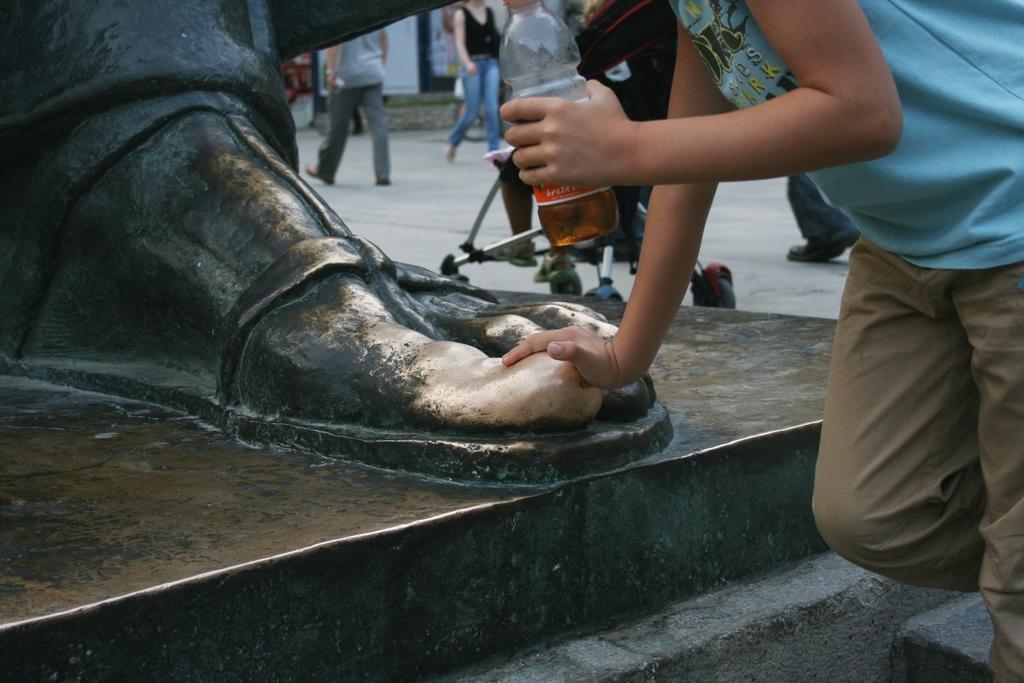Could you give a brief overview of what you see in this image? In this image I can see a sculpture and a group of people on the road. This image is taken may be during a day on the road. 